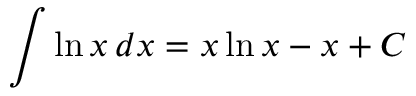Convert formula to latex. <formula><loc_0><loc_0><loc_500><loc_500>\int \ln x \, d x = x \ln x - x + C</formula> 